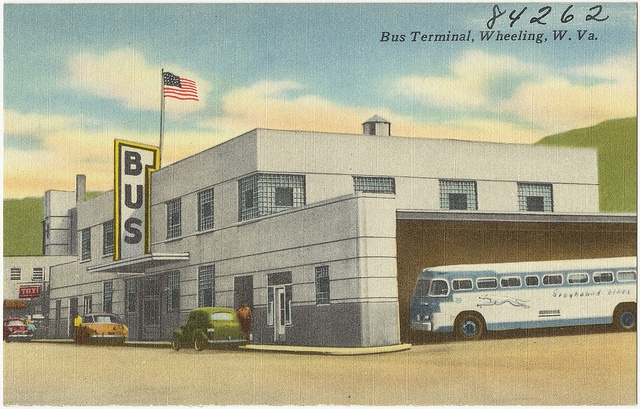Describe the objects in this image and their specific colors. I can see bus in white, beige, gray, and darkgray tones, car in white, darkgreen, olive, gray, and black tones, car in white, gray, tan, and darkgray tones, car in white, gray, darkgray, brown, and maroon tones, and people in white, maroon, gray, and brown tones in this image. 